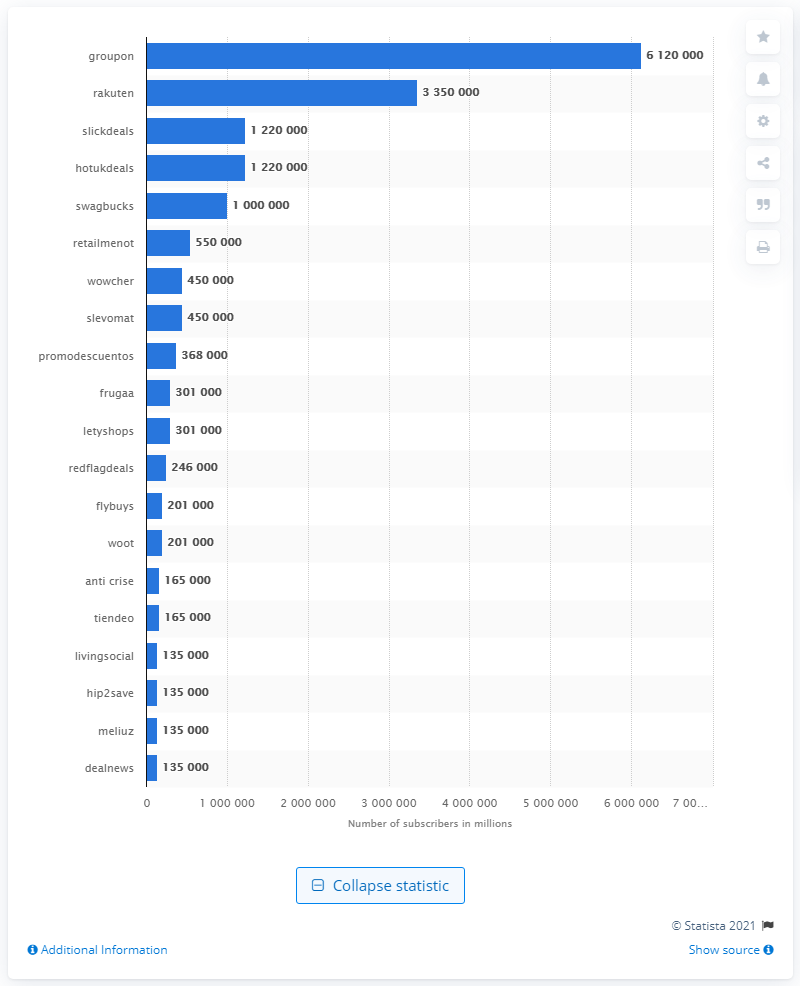Identify some key points in this picture. In June 2020, Groupon generated approximately 6,120,000 searches. 